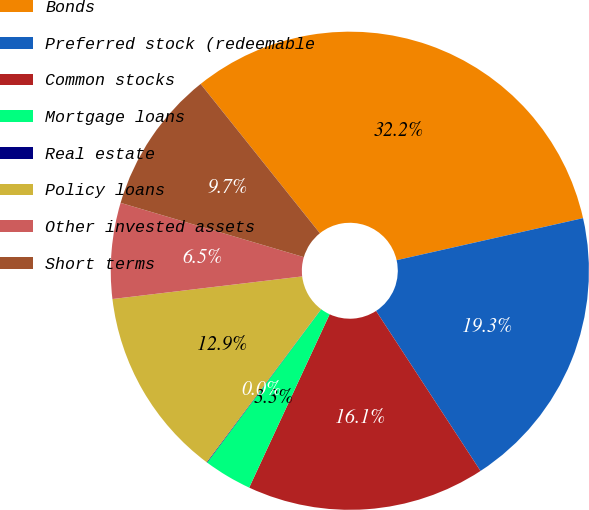Convert chart to OTSL. <chart><loc_0><loc_0><loc_500><loc_500><pie_chart><fcel>Bonds<fcel>Preferred stock (redeemable<fcel>Common stocks<fcel>Mortgage loans<fcel>Real estate<fcel>Policy loans<fcel>Other invested assets<fcel>Short terms<nl><fcel>32.2%<fcel>19.33%<fcel>16.12%<fcel>3.26%<fcel>0.04%<fcel>12.9%<fcel>6.47%<fcel>9.69%<nl></chart> 